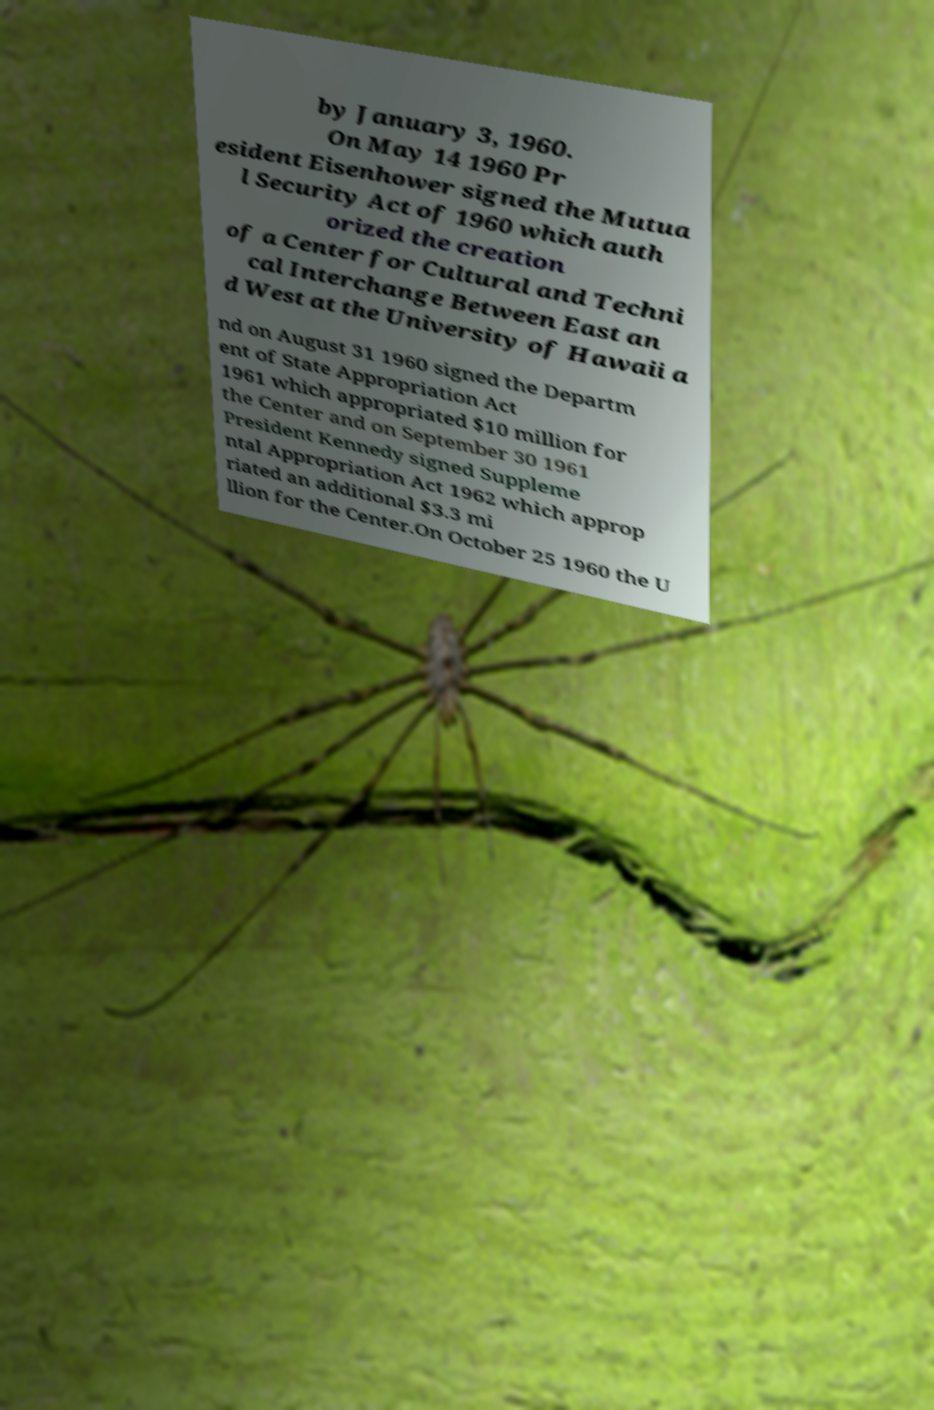Could you assist in decoding the text presented in this image and type it out clearly? by January 3, 1960. On May 14 1960 Pr esident Eisenhower signed the Mutua l Security Act of 1960 which auth orized the creation of a Center for Cultural and Techni cal Interchange Between East an d West at the University of Hawaii a nd on August 31 1960 signed the Departm ent of State Appropriation Act 1961 which appropriated $10 million for the Center and on September 30 1961 President Kennedy signed Suppleme ntal Appropriation Act 1962 which approp riated an additional $3.3 mi llion for the Center.On October 25 1960 the U 